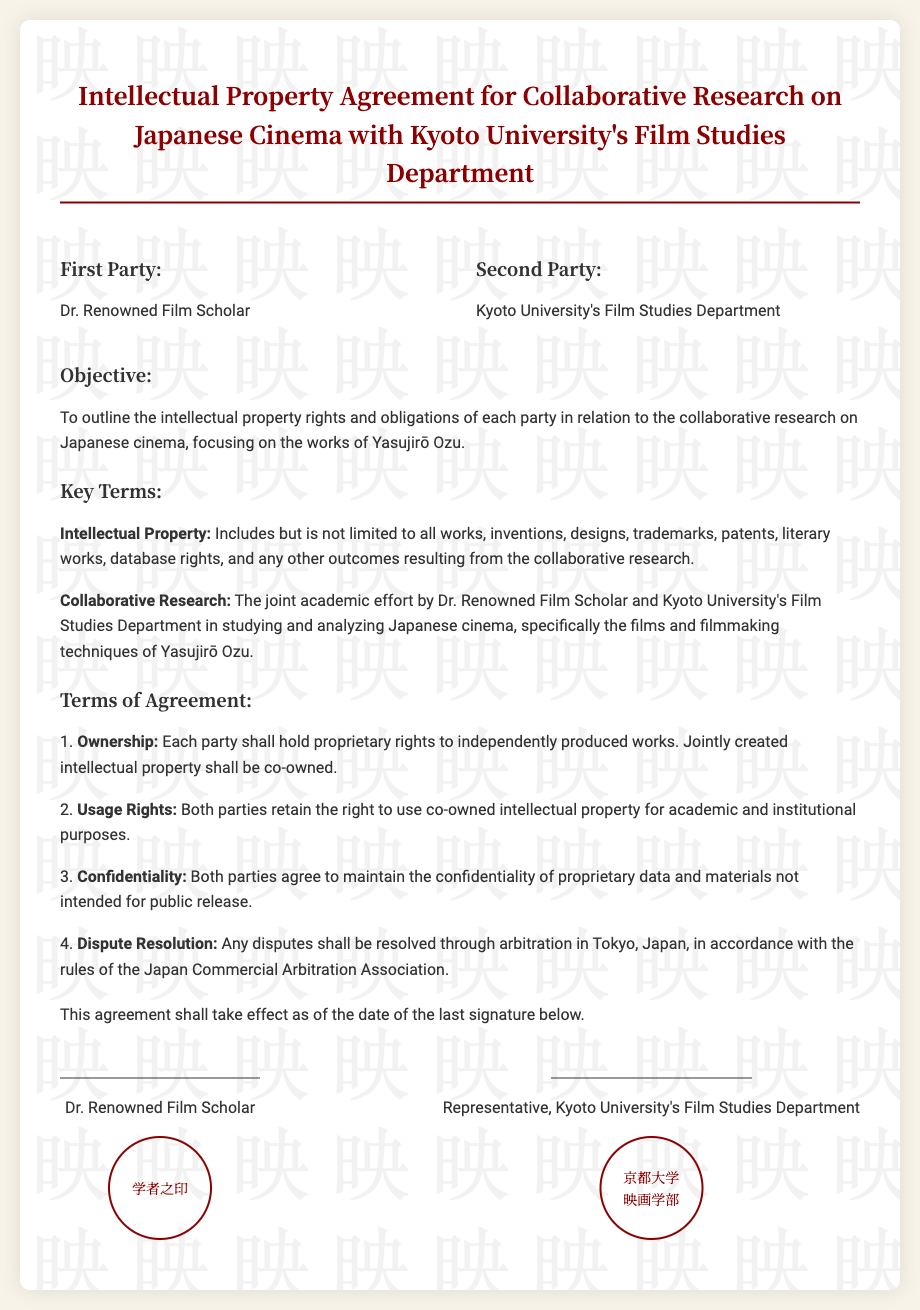What is the title of the agreement? The title indicates the nature of the document, which is an Intellectual Property Agreement specifically related to collaborative research.
Answer: Intellectual Property Agreement for Collaborative Research on Japanese Cinema with Kyoto University's Film Studies Department Who is the first party named in the agreement? The first party listed in the document is a person involved in the agreement.
Answer: Dr. Renowned Film Scholar What is the main focus of the collaborative research? The objective section highlights the specific area of research collaboration between the parties involved.
Answer: Japanese cinema, focusing on the works of Yasujirō Ozu What are the ownership rights according to the agreement? The agreement specifies how ownership is determined for intellectual property that is created in collaboration.
Answer: Each party shall hold proprietary rights to independently produced works; jointly created intellectual property shall be co-owned Where will disputes be resolved? The agreement provides a geographic location for resolving conflicts between the parties involved.
Answer: Tokyo, Japan What type of intellectual property is included in this agreement? The document specifies various forms of intellectual property that fall under the agreement's scope.
Answer: All works, inventions, designs, trademarks, patents, literary works, database rights Who represents the second party? The agreement identifies a specific title in the second party's representation.
Answer: Representative, Kyoto University's Film Studies Department What is the confidentiality clause about? The terms outline the responsibilities regarding proprietary information between the parties.
Answer: Maintain the confidentiality of proprietary data and materials not intended for public release 